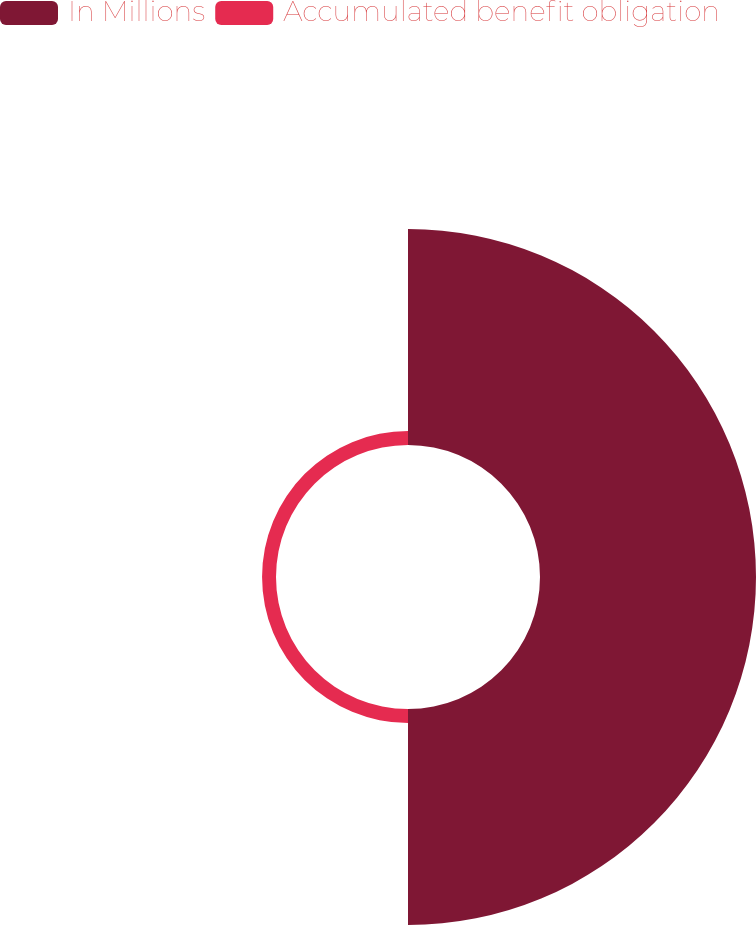Convert chart to OTSL. <chart><loc_0><loc_0><loc_500><loc_500><pie_chart><fcel>In Millions<fcel>Accumulated benefit obligation<nl><fcel>93.94%<fcel>6.06%<nl></chart> 